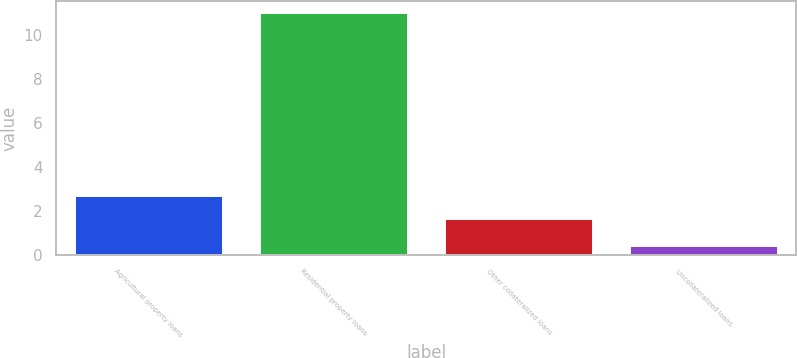<chart> <loc_0><loc_0><loc_500><loc_500><bar_chart><fcel>Agricultural property loans<fcel>Residential property loans<fcel>Other collateralized loans<fcel>Uncollateralized loans<nl><fcel>2.69<fcel>11<fcel>1.63<fcel>0.39<nl></chart> 